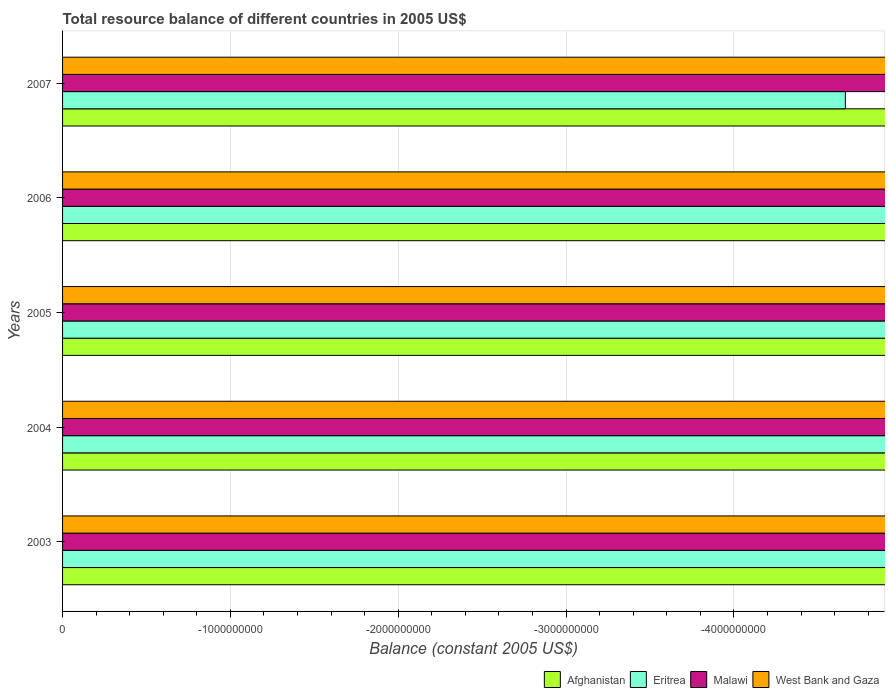Are the number of bars per tick equal to the number of legend labels?
Make the answer very short. No. How many bars are there on the 3rd tick from the bottom?
Provide a short and direct response. 0. What is the label of the 5th group of bars from the top?
Your answer should be compact. 2003. Across all years, what is the minimum total resource balance in Afghanistan?
Give a very brief answer. 0. What is the total total resource balance in Malawi in the graph?
Give a very brief answer. 0. What is the difference between the total resource balance in Afghanistan in 2004 and the total resource balance in Malawi in 2007?
Offer a very short reply. 0. In how many years, is the total resource balance in Afghanistan greater than the average total resource balance in Afghanistan taken over all years?
Provide a short and direct response. 0. Is it the case that in every year, the sum of the total resource balance in Afghanistan and total resource balance in Malawi is greater than the sum of total resource balance in Eritrea and total resource balance in West Bank and Gaza?
Ensure brevity in your answer.  No. Is it the case that in every year, the sum of the total resource balance in Malawi and total resource balance in Afghanistan is greater than the total resource balance in Eritrea?
Offer a terse response. No. How many bars are there?
Your answer should be very brief. 0. What is the difference between two consecutive major ticks on the X-axis?
Keep it short and to the point. 1.00e+09. Where does the legend appear in the graph?
Offer a very short reply. Bottom right. How many legend labels are there?
Ensure brevity in your answer.  4. What is the title of the graph?
Give a very brief answer. Total resource balance of different countries in 2005 US$. Does "South Sudan" appear as one of the legend labels in the graph?
Ensure brevity in your answer.  No. What is the label or title of the X-axis?
Offer a terse response. Balance (constant 2005 US$). What is the label or title of the Y-axis?
Offer a very short reply. Years. What is the Balance (constant 2005 US$) of Afghanistan in 2003?
Provide a short and direct response. 0. What is the Balance (constant 2005 US$) of Eritrea in 2003?
Offer a terse response. 0. What is the Balance (constant 2005 US$) in Afghanistan in 2004?
Your response must be concise. 0. What is the Balance (constant 2005 US$) in Afghanistan in 2005?
Ensure brevity in your answer.  0. What is the Balance (constant 2005 US$) in Eritrea in 2005?
Provide a succinct answer. 0. What is the Balance (constant 2005 US$) in Afghanistan in 2006?
Your response must be concise. 0. What is the Balance (constant 2005 US$) in Eritrea in 2006?
Ensure brevity in your answer.  0. What is the Balance (constant 2005 US$) of Malawi in 2006?
Your response must be concise. 0. What is the Balance (constant 2005 US$) in West Bank and Gaza in 2006?
Your response must be concise. 0. What is the Balance (constant 2005 US$) of Afghanistan in 2007?
Give a very brief answer. 0. What is the Balance (constant 2005 US$) of Malawi in 2007?
Offer a very short reply. 0. What is the Balance (constant 2005 US$) in West Bank and Gaza in 2007?
Offer a very short reply. 0. What is the total Balance (constant 2005 US$) in Afghanistan in the graph?
Your answer should be very brief. 0. What is the average Balance (constant 2005 US$) in Afghanistan per year?
Your answer should be very brief. 0. What is the average Balance (constant 2005 US$) in Eritrea per year?
Give a very brief answer. 0. What is the average Balance (constant 2005 US$) of West Bank and Gaza per year?
Give a very brief answer. 0. 